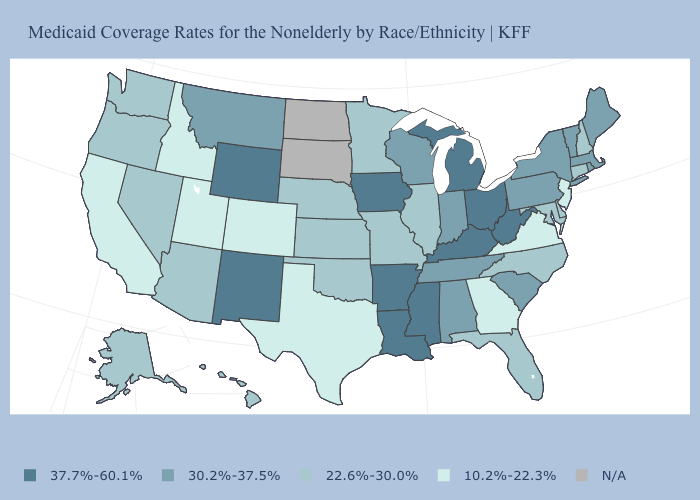What is the lowest value in states that border Ohio?
Quick response, please. 30.2%-37.5%. Name the states that have a value in the range 10.2%-22.3%?
Short answer required. California, Colorado, Georgia, Idaho, New Jersey, Texas, Utah, Virginia. Name the states that have a value in the range 22.6%-30.0%?
Be succinct. Alaska, Arizona, Connecticut, Delaware, Florida, Hawaii, Illinois, Kansas, Maryland, Minnesota, Missouri, Nebraska, Nevada, New Hampshire, North Carolina, Oklahoma, Oregon, Washington. Name the states that have a value in the range 30.2%-37.5%?
Concise answer only. Alabama, Indiana, Maine, Massachusetts, Montana, New York, Pennsylvania, Rhode Island, South Carolina, Tennessee, Vermont, Wisconsin. What is the value of North Dakota?
Answer briefly. N/A. Name the states that have a value in the range 30.2%-37.5%?
Give a very brief answer. Alabama, Indiana, Maine, Massachusetts, Montana, New York, Pennsylvania, Rhode Island, South Carolina, Tennessee, Vermont, Wisconsin. What is the lowest value in the MidWest?
Be succinct. 22.6%-30.0%. Name the states that have a value in the range 22.6%-30.0%?
Write a very short answer. Alaska, Arizona, Connecticut, Delaware, Florida, Hawaii, Illinois, Kansas, Maryland, Minnesota, Missouri, Nebraska, Nevada, New Hampshire, North Carolina, Oklahoma, Oregon, Washington. Does Hawaii have the lowest value in the West?
Write a very short answer. No. Name the states that have a value in the range 22.6%-30.0%?
Concise answer only. Alaska, Arizona, Connecticut, Delaware, Florida, Hawaii, Illinois, Kansas, Maryland, Minnesota, Missouri, Nebraska, Nevada, New Hampshire, North Carolina, Oklahoma, Oregon, Washington. Does Mississippi have the highest value in the USA?
Concise answer only. Yes. Among the states that border Vermont , does Massachusetts have the highest value?
Concise answer only. Yes. What is the value of Mississippi?
Answer briefly. 37.7%-60.1%. Name the states that have a value in the range 37.7%-60.1%?
Write a very short answer. Arkansas, Iowa, Kentucky, Louisiana, Michigan, Mississippi, New Mexico, Ohio, West Virginia, Wyoming. 